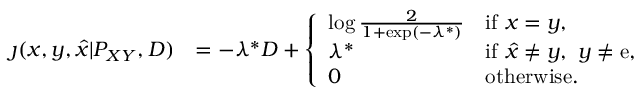Convert formula to latex. <formula><loc_0><loc_0><loc_500><loc_500>\begin{array} { r l } { \jmath ( x , y , \hat { x } | P _ { X Y } , D ) } & { = - \lambda ^ { * } D + \left \{ \begin{array} { l l } { \log \frac { 2 } { 1 + \exp ( - \lambda ^ { * } ) } } & { i f x = y , } \\ { \lambda ^ { * } } & { i f \hat { x } \neq y , y \neq e , } \\ { 0 } & { o t h e r w i s e . } \end{array} } \end{array}</formula> 